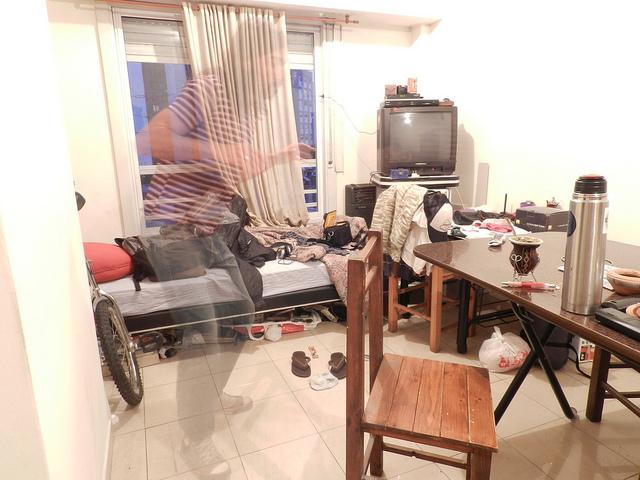The way the person appears makes them look like what type of being? ghost 